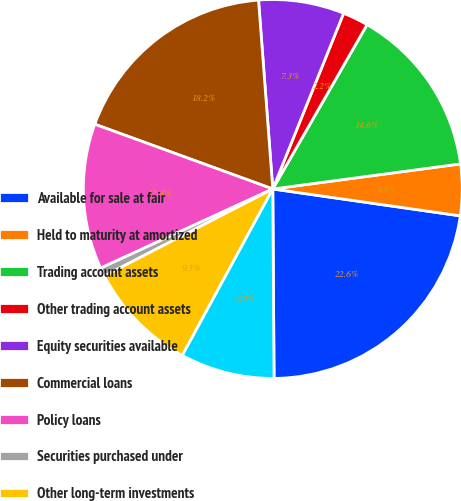Convert chart to OTSL. <chart><loc_0><loc_0><loc_500><loc_500><pie_chart><fcel>Available for sale at fair<fcel>Held to maturity at amortized<fcel>Trading account assets<fcel>Other trading account assets<fcel>Equity securities available<fcel>Commercial loans<fcel>Policy loans<fcel>Securities purchased under<fcel>Other long-term investments<fcel>Short-term investments<nl><fcel>22.63%<fcel>4.38%<fcel>14.6%<fcel>2.19%<fcel>7.3%<fcel>18.25%<fcel>12.41%<fcel>0.73%<fcel>9.49%<fcel>8.03%<nl></chart> 